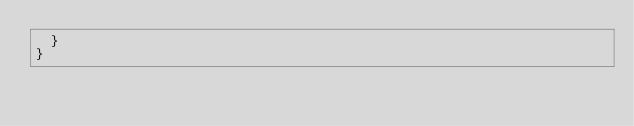Convert code to text. <code><loc_0><loc_0><loc_500><loc_500><_TypeScript_>  }
}
</code> 